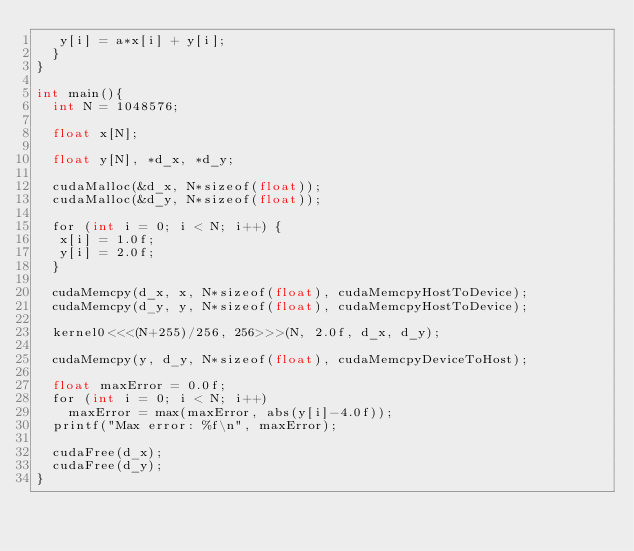Convert code to text. <code><loc_0><loc_0><loc_500><loc_500><_Cuda_>	 y[i] = a*x[i] + y[i];
  }
}

int main(){
  int N = 1048576;

  float x[N];

  float y[N], *d_x, *d_y;

  cudaMalloc(&d_x, N*sizeof(float)); 
  cudaMalloc(&d_y, N*sizeof(float));

  for (int i = 0; i < N; i++) {
   x[i] = 1.0f;
   y[i] = 2.0f;
  }

  cudaMemcpy(d_x, x, N*sizeof(float), cudaMemcpyHostToDevice);
  cudaMemcpy(d_y, y, N*sizeof(float), cudaMemcpyHostToDevice);

  kernel0<<<(N+255)/256, 256>>>(N, 2.0f, d_x, d_y);

  cudaMemcpy(y, d_y, N*sizeof(float), cudaMemcpyDeviceToHost);

  float maxError = 0.0f;
  for (int i = 0; i < N; i++)
    maxError = max(maxError, abs(y[i]-4.0f));
  printf("Max error: %f\n", maxError);

  cudaFree(d_x);
  cudaFree(d_y);
}
</code> 